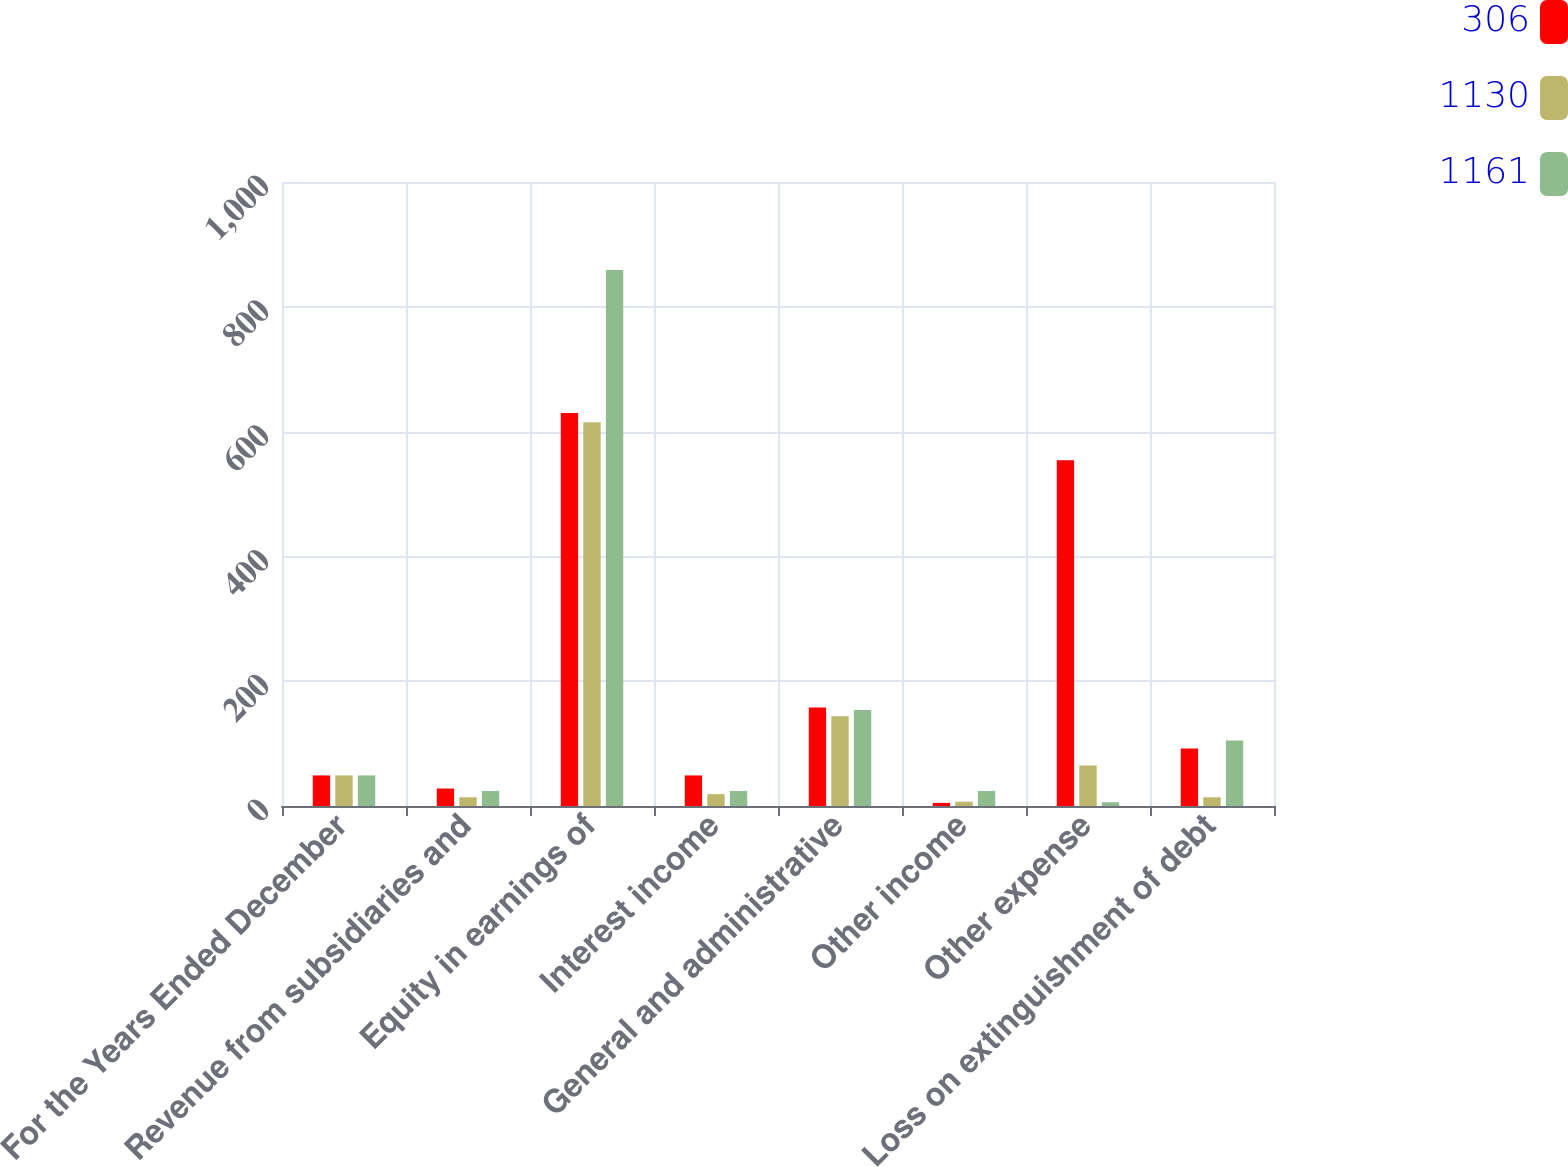<chart> <loc_0><loc_0><loc_500><loc_500><stacked_bar_chart><ecel><fcel>For the Years Ended December<fcel>Revenue from subsidiaries and<fcel>Equity in earnings of<fcel>Interest income<fcel>General and administrative<fcel>Other income<fcel>Other expense<fcel>Loss on extinguishment of debt<nl><fcel>306<fcel>49<fcel>28<fcel>630<fcel>49<fcel>158<fcel>5<fcel>554<fcel>92<nl><fcel>1130<fcel>49<fcel>14<fcel>615<fcel>19<fcel>144<fcel>7<fcel>65<fcel>14<nl><fcel>1161<fcel>49<fcel>24<fcel>859<fcel>24<fcel>154<fcel>24<fcel>6<fcel>105<nl></chart> 